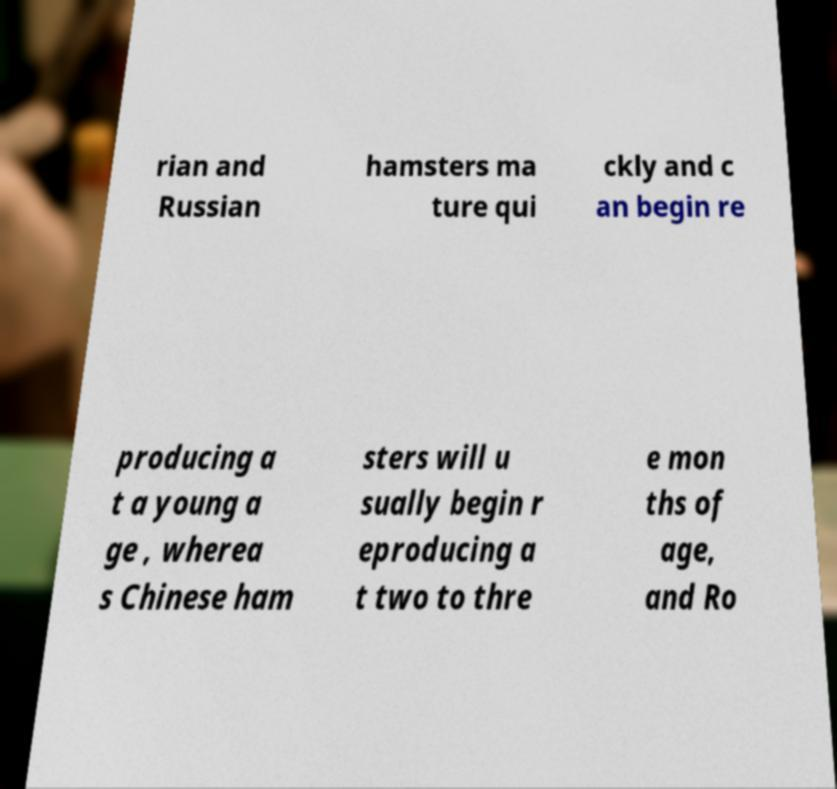I need the written content from this picture converted into text. Can you do that? rian and Russian hamsters ma ture qui ckly and c an begin re producing a t a young a ge , wherea s Chinese ham sters will u sually begin r eproducing a t two to thre e mon ths of age, and Ro 